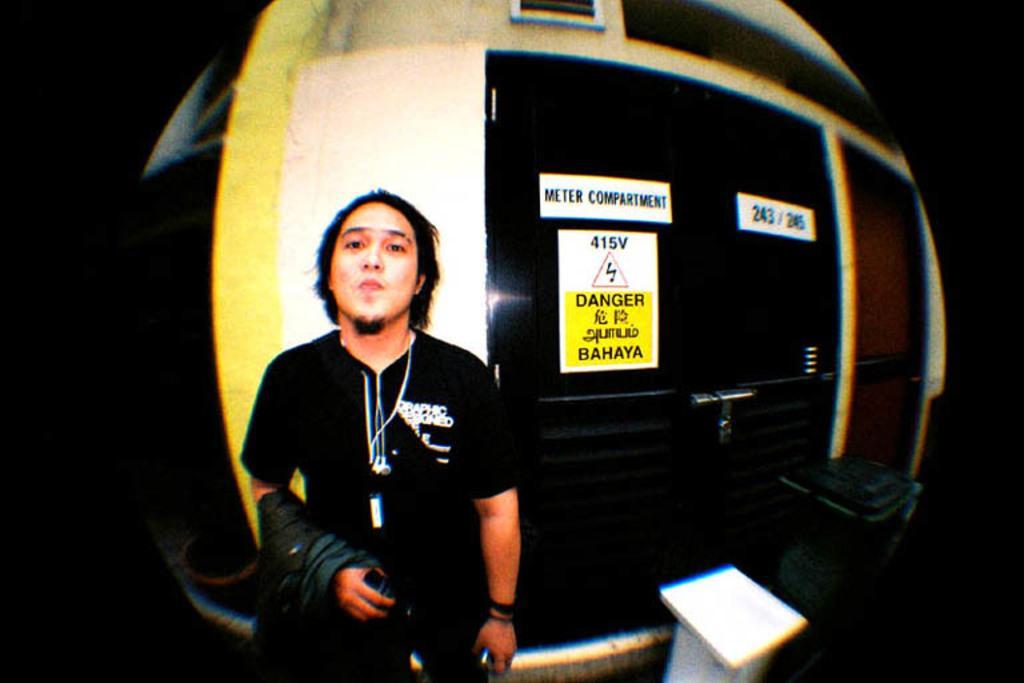Can you describe this image briefly? In this image, we can see a man holding coat in this hand and in the background, we can see some plate plates. 